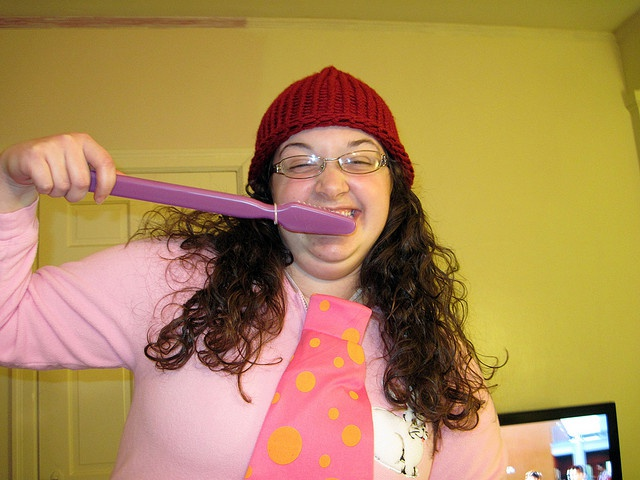Describe the objects in this image and their specific colors. I can see people in olive, lightpink, black, maroon, and pink tones, tie in olive, lightpink, salmon, and orange tones, tv in olive, black, white, and tan tones, and toothbrush in olive, purple, lightpink, and violet tones in this image. 